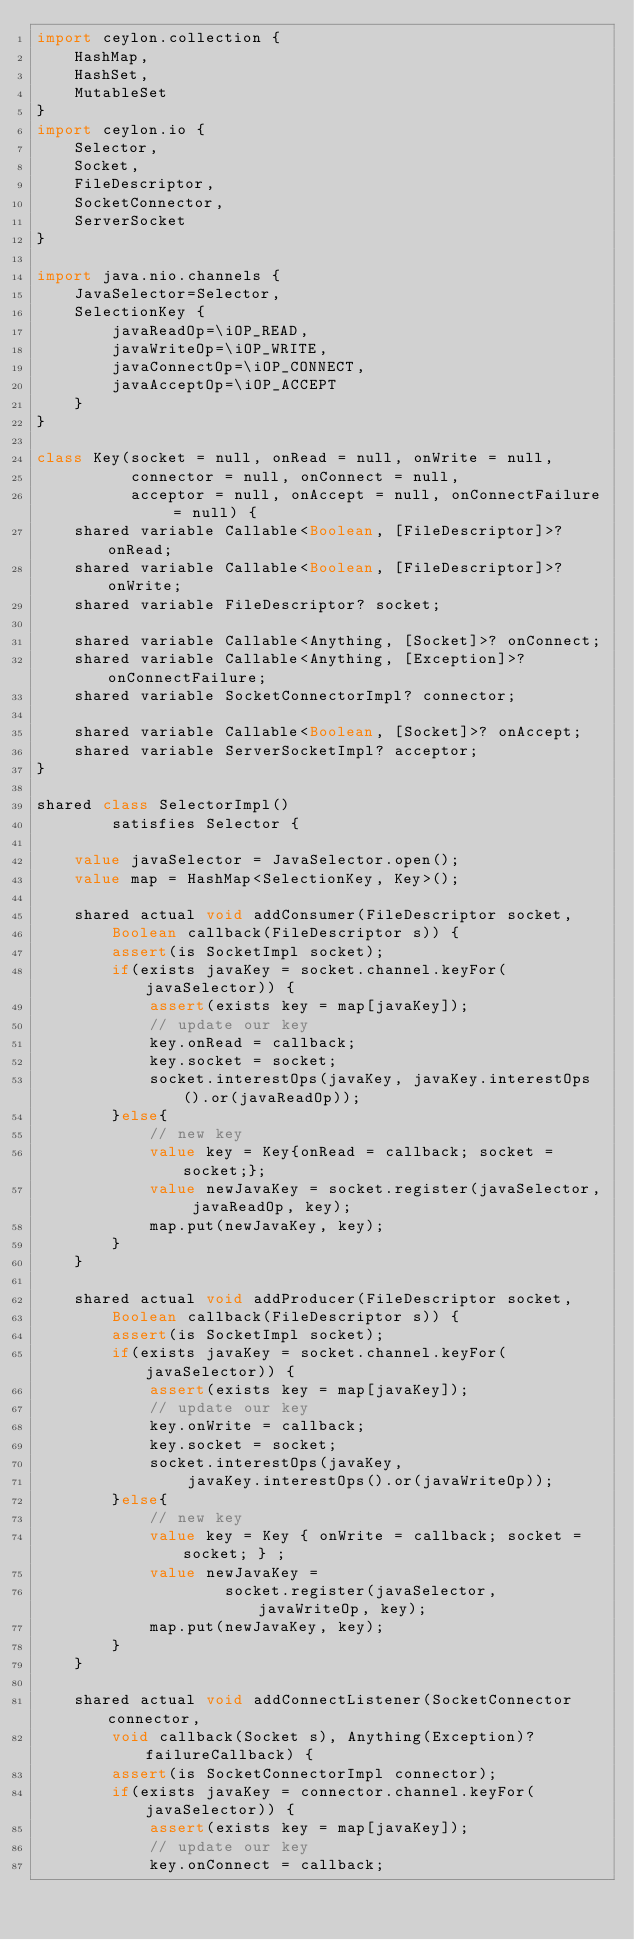Convert code to text. <code><loc_0><loc_0><loc_500><loc_500><_Ceylon_>import ceylon.collection {
    HashMap,
    HashSet,
    MutableSet
}
import ceylon.io {
    Selector,
    Socket,
    FileDescriptor,
    SocketConnector,
    ServerSocket
}

import java.nio.channels {
    JavaSelector=Selector,
    SelectionKey {
        javaReadOp=\iOP_READ,
        javaWriteOp=\iOP_WRITE,
        javaConnectOp=\iOP_CONNECT,
        javaAcceptOp=\iOP_ACCEPT
    }
}

class Key(socket = null, onRead = null, onWrite = null, 
          connector = null, onConnect = null,
          acceptor = null, onAccept = null, onConnectFailure = null) {
    shared variable Callable<Boolean, [FileDescriptor]>? onRead;
    shared variable Callable<Boolean, [FileDescriptor]>? onWrite;
    shared variable FileDescriptor? socket;
    
    shared variable Callable<Anything, [Socket]>? onConnect;
    shared variable Callable<Anything, [Exception]>? onConnectFailure;
    shared variable SocketConnectorImpl? connector;
    
    shared variable Callable<Boolean, [Socket]>? onAccept;
    shared variable ServerSocketImpl? acceptor;
}

shared class SelectorImpl() 
        satisfies Selector {
    
    value javaSelector = JavaSelector.open();
    value map = HashMap<SelectionKey, Key>();
    
    shared actual void addConsumer(FileDescriptor socket, 
        Boolean callback(FileDescriptor s)) {
        assert(is SocketImpl socket);
        if(exists javaKey = socket.channel.keyFor(javaSelector)) {
            assert(exists key = map[javaKey]);
            // update our key
            key.onRead = callback;
            key.socket = socket;
            socket.interestOps(javaKey, javaKey.interestOps().or(javaReadOp));
        }else{
            // new key
            value key = Key{onRead = callback; socket = socket;};
            value newJavaKey = socket.register(javaSelector, javaReadOp, key);
            map.put(newJavaKey, key);
        }
    }

    shared actual void addProducer(FileDescriptor socket, 
        Boolean callback(FileDescriptor s)) {
        assert(is SocketImpl socket);
        if(exists javaKey = socket.channel.keyFor(javaSelector)) {
            assert(exists key = map[javaKey]);
            // update our key
            key.onWrite = callback;
            key.socket = socket;
            socket.interestOps(javaKey, 
                javaKey.interestOps().or(javaWriteOp));
        }else{
            // new key
            value key = Key { onWrite = callback; socket = socket; } ;
            value newJavaKey = 
                    socket.register(javaSelector, javaWriteOp, key);
            map.put(newJavaKey, key);
        }
    }

    shared actual void addConnectListener(SocketConnector connector, 
        void callback(Socket s), Anything(Exception)? failureCallback) {
        assert(is SocketConnectorImpl connector);
        if(exists javaKey = connector.channel.keyFor(javaSelector)) {
            assert(exists key = map[javaKey]);
            // update our key
            key.onConnect = callback;</code> 